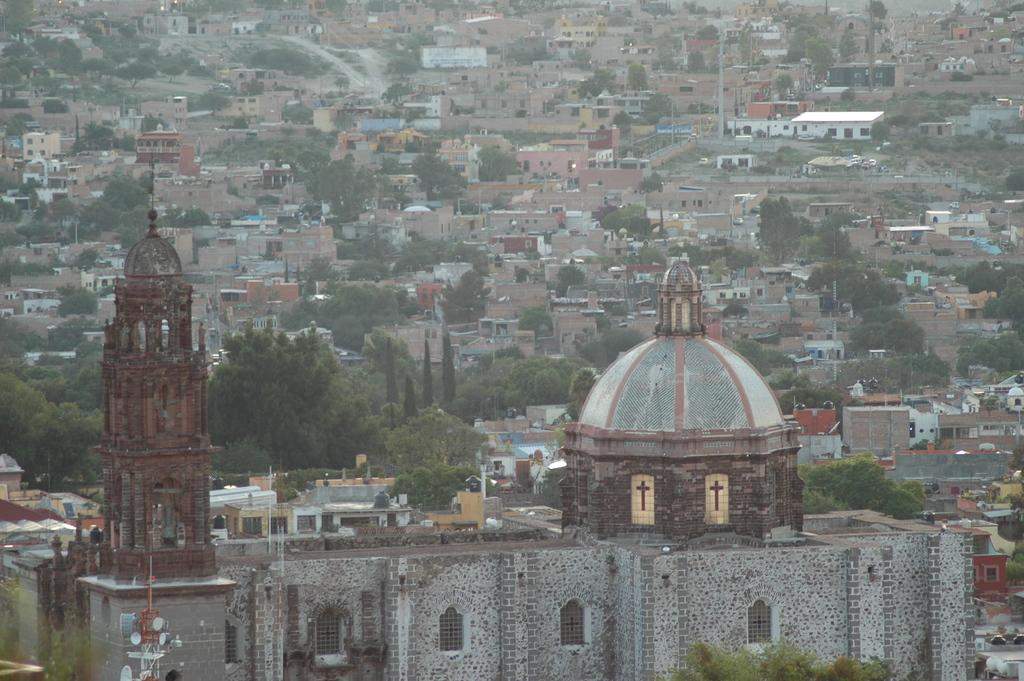What type of view is shown in the image? The image is an aerial view of a city. What natural elements can be seen in the image? There are trees in the image. What man-made structures are visible in the image? There are buildings, roads, and poles in the image. Are there any other objects present in the image? Yes, there are other objects in the image. What can be seen in the foreground of the image? In the foreground, there is a church. What type of garden can be seen in the image? There is no garden present in the image; it is an aerial view of a city with buildings, roads, trees, and other objects. What type of ray is visible in the image? There is no ray visible in the image; it is an aerial view of a city with buildings, roads, trees, and other objects. 